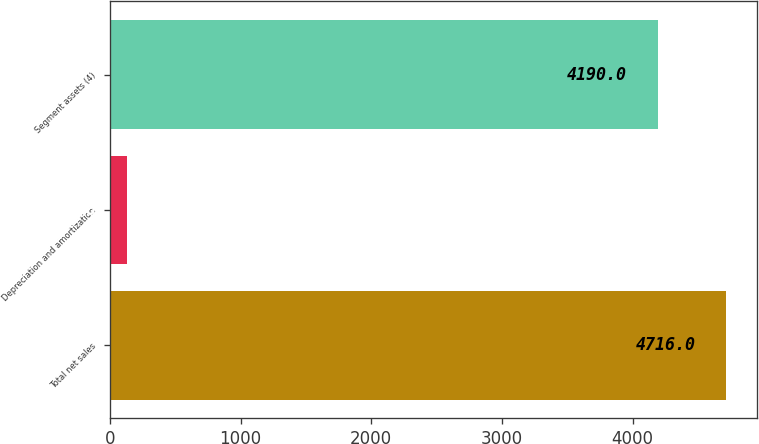Convert chart to OTSL. <chart><loc_0><loc_0><loc_500><loc_500><bar_chart><fcel>Total net sales<fcel>Depreciation and amortization<fcel>Segment assets (4)<nl><fcel>4716<fcel>133<fcel>4190<nl></chart> 